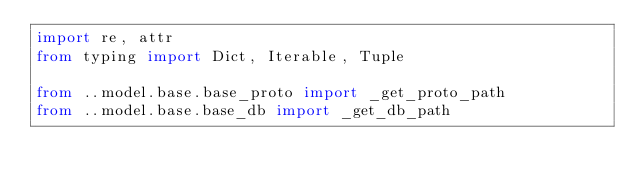<code> <loc_0><loc_0><loc_500><loc_500><_Python_>import re, attr
from typing import Dict, Iterable, Tuple

from ..model.base.base_proto import _get_proto_path
from ..model.base.base_db import _get_db_path

</code> 